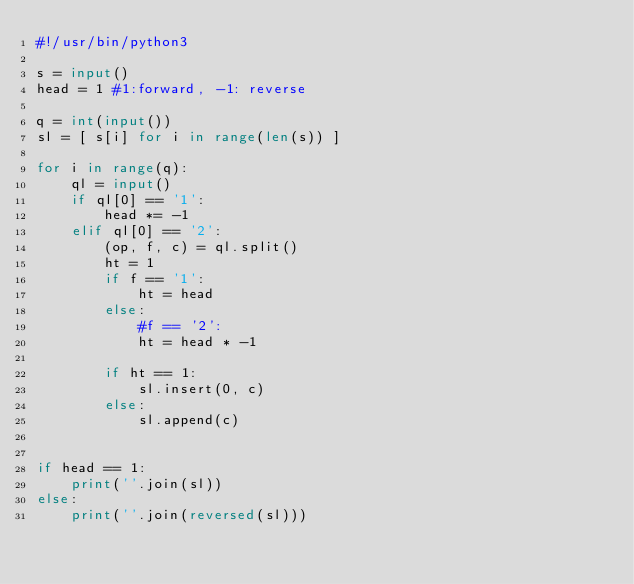Convert code to text. <code><loc_0><loc_0><loc_500><loc_500><_Python_>#!/usr/bin/python3

s = input()
head = 1 #1:forward, -1: reverse

q = int(input())
sl = [ s[i] for i in range(len(s)) ]

for i in range(q):
    ql = input()
    if ql[0] == '1':
        head *= -1
    elif ql[0] == '2':
        (op, f, c) = ql.split()
        ht = 1
        if f == '1':
            ht = head
        else:
            #f == '2':
            ht = head * -1

        if ht == 1:
            sl.insert(0, c)
        else:
            sl.append(c)


if head == 1:
    print(''.join(sl))
else:
    print(''.join(reversed(sl)))
</code> 